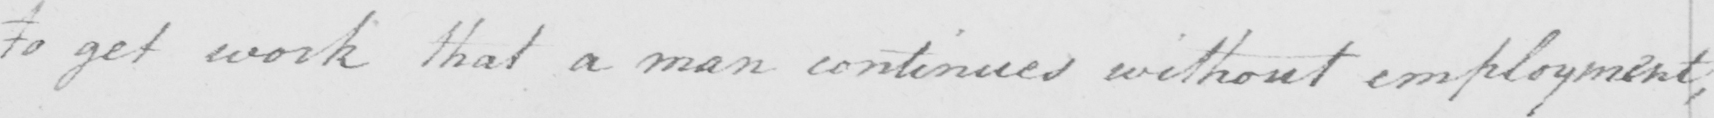Can you read and transcribe this handwriting? to get work that a man continues without employment , 